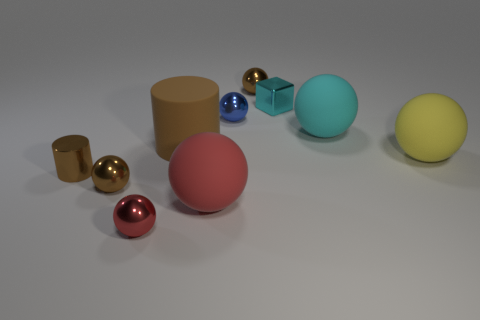Subtract all cyan rubber balls. How many balls are left? 6 Subtract all red blocks. How many brown balls are left? 2 Subtract all blue spheres. How many spheres are left? 6 Subtract all blue spheres. Subtract all purple blocks. How many spheres are left? 6 Subtract all balls. How many objects are left? 3 Add 1 brown metal objects. How many brown metal objects are left? 4 Add 4 brown shiny cylinders. How many brown shiny cylinders exist? 5 Subtract 0 green spheres. How many objects are left? 10 Subtract all tiny gray cylinders. Subtract all cylinders. How many objects are left? 8 